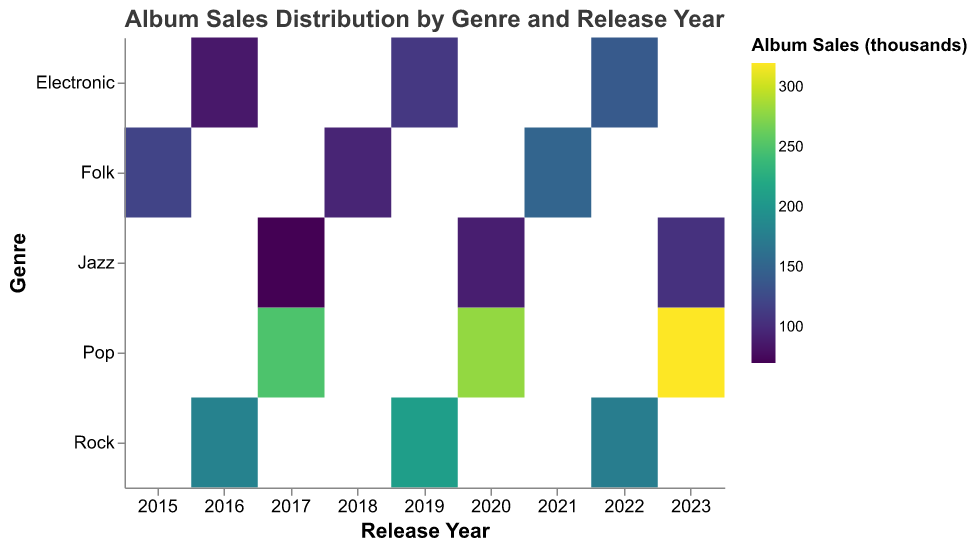What is the title of the figure? The title of the figure is usually located at the top and describes what the chart is about. In this case, it is "Album Sales Distribution by Genre and Release Year".
Answer: Album Sales Distribution by Genre and Release Year Which genre had the highest album sales in 2023? To find the genre with the highest album sales in 2023, look at the rectangles corresponding to 2023 and compare their color intensities. The brightest color indicates the highest sales. Here, Pop has the brightest color.
Answer: Pop What is the trend in album sales for the Rock genre from 2016 to 2022? To observe the trend, examine the colors of the rectangles for the Rock genre from 2016 to 2022. From 2016 (dark color) to 2019 (brighter color), there is an increase, but from 2019 to 2022 (slightly darker), there is a decrease.
Answer: Increased until 2019, then decreased How many years had Folk albums with sales higher than 100,000 units? For each year in the Folk genre, check if the color intensity represents sales higher than 100,000. In this case, Folk has higher sales in 2015 and 2021.
Answer: 2 years Which genre had the lowest album sales overall? To determine this, compare the overall color intensity (darkest shades) across all genres. Jazz has consistently darker colors, indicating lower sales.
Answer: Jazz What was the album sales trend for Jazz from 2017 to 2023? Examine the color progression for Jazz from 2017 to 2023. The color becomes progressively lighter, indicating an increase in sales over the years.
Answer: Increasing Was there any year where Electronic albums had sales between 100,000 and 120,000 units? Look at the colors of Electronic genre rectangles for each year and match them to the color gradient legend for the range 100,000 to 120,000. In 2019, the sales fall within this range.
Answer: 2019 Compare the album sales between Folk in 2018 and Electronic in 2022. Which had higher sales? Check the colors of Folk in 2018 and Electronic in 2022 and refer to the color gradient for sales. Folk in 2018 has a darker color compared to Electronic in 2022, indicating lower sales.
Answer: Electronic in 2022 had higher sales What is the difference in album sales between Pop in 2020 and Jazz in 2020? Check the color intensities for Pop and Jazz in 2020. Referring to the color gradient, Pop in 2020 has lighter color (280,000) and Jazz in 2020 (90,000). Subtract to find the difference: 280 - 90 = 190.
Answer: 190,000 units 